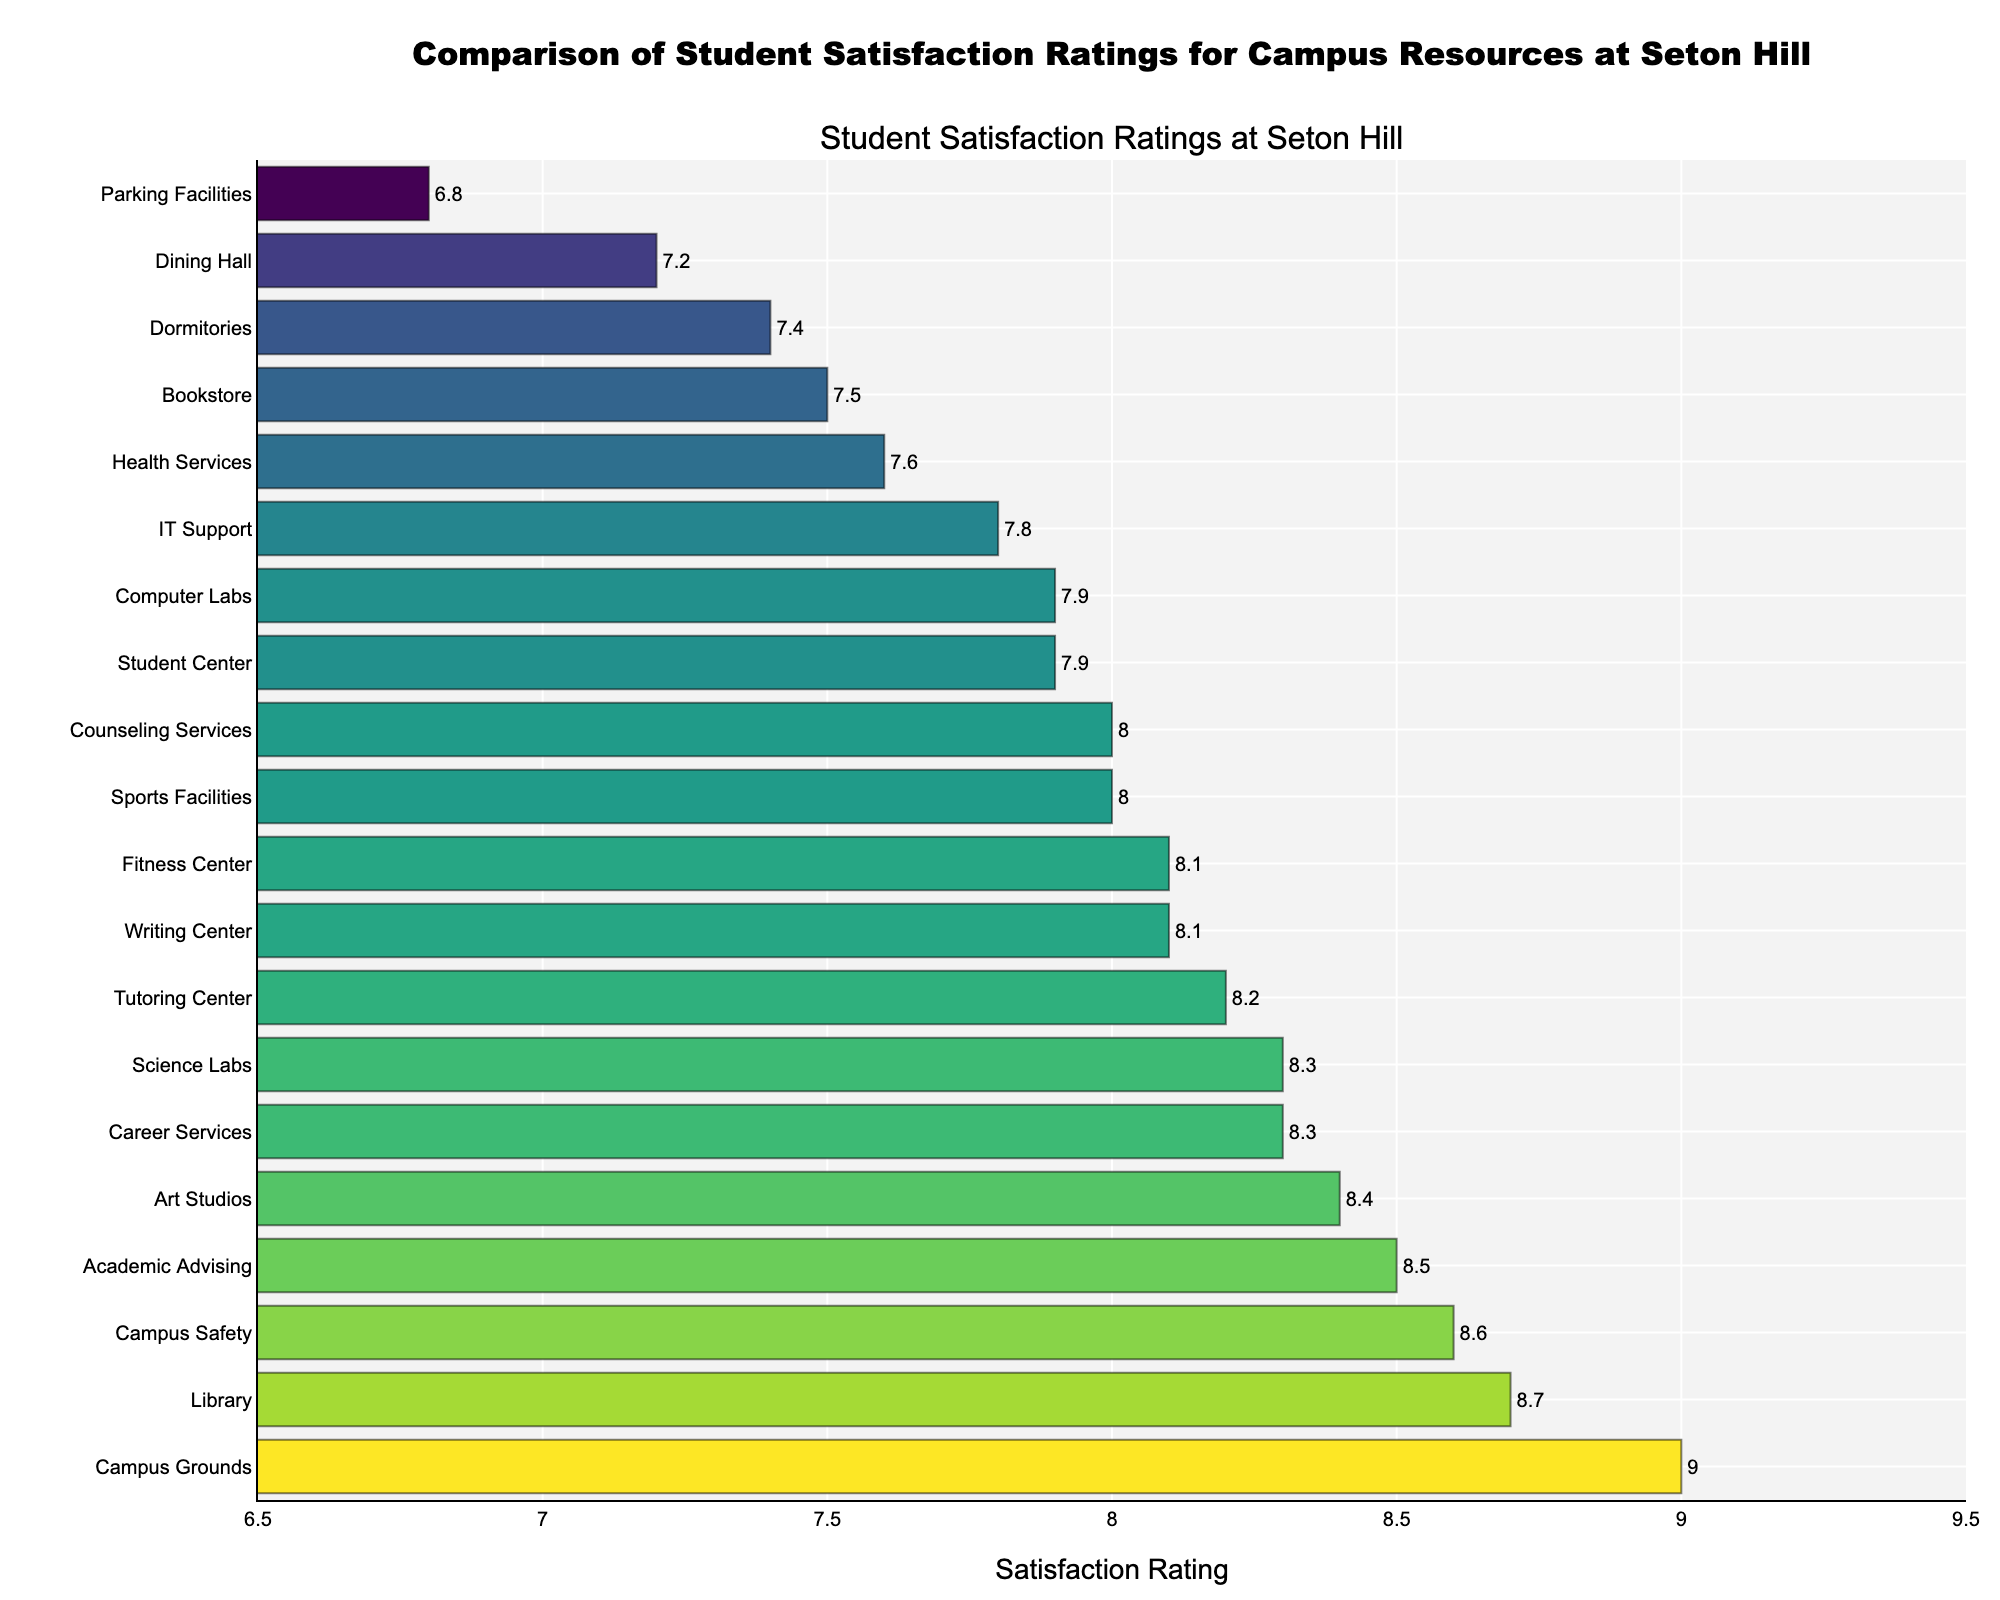Which campus resource has the highest student satisfaction rating? The highest bar in the chart represents the resource with the highest satisfaction rating. The Campus Grounds has the highest satisfaction rating listed at 9.0.
Answer: Campus Grounds Which campus resource has the lowest student satisfaction rating? The lowest bar in the chart represents the resource with the lowest satisfaction rating. Parking Facilities has the lowest satisfaction rating listed at 6.8.
Answer: Parking Facilities How much higher is the satisfaction rating for the Library compared to the Parking Facilities? The satisfaction rating for the Library is 8.7 and for the Parking Facilities is 6.8. The difference is 8.7 - 6.8 = 1.9.
Answer: 1.9 What are the resources with satisfaction ratings above 8.0? The bars that extend beyond the satisfaction rating of 8.0 correspond to resources with ratings above 8.0. They are Campus Grounds, Library, Campus Safety, Academic Advising, Art Studios, Career Services, Science Labs, Tutoring Center, and Fitness Center.
Answer: Campus Grounds, Library, Campus Safety, Academic Advising, Art Studios, Career Services, Science Labs, Tutoring Center, Fitness Center Which resources have a satisfaction rating exactly equal to 8.0? The bar aligned with the satisfaction rating of 8.0 represents the applicable resources, which are Counseling Services and Sports Facilities.
Answer: Counseling Services, Sports Facilities What is the average satisfaction rating for the Student Center and the IT Support? The ratings for Student Center and IT Support are 7.9 and 7.8 respectively. The average is (7.9 + 7.8) / 2 = 7.85.
Answer: 7.85 What is the difference between the highest and the lowest satisfaction rating? The highest satisfaction rating is for Campus Grounds (9.0) and the lowest is for Parking Facilities (6.8). The difference is 9.0 - 6.8 = 2.2.
Answer: 2.2 Are there more resources with ratings above or below 8.0? Count the number of resources above 8.0 and below 8.0. There are 9 resources above 8.0 and 11 below 8.0. Therefore, there are more resources with ratings below 8.0.
Answer: Below 8.0 What is the median satisfaction rating of all resources listed? To find the median, list all the ratings in ascending order and find the middle value. The sorted ratings are 6.8, 7.2, 7.4, 7.5, 7.6, 7.8, 7.9, 7.9, 8.0, 8.0, 8.1, 8.1, 8.2, 8.3, 8.3, 8.4, 8.5, 8.6, 8.7, 9.0. There are 20 ratings, so the median will be the average of the 10th and 11th values: (8.0 + 8.1) / 2 = 8.05.
Answer: 8.05 Does the Academic Advising rating stand out visually on the chart? Looking at the visual properties such as the color and length of the bar, the Academic Advising bar is one of the higher ones but not the highest. It does not stand out the most visually compared to other higher ratings like Campus Grounds or the Library.
Answer: No 